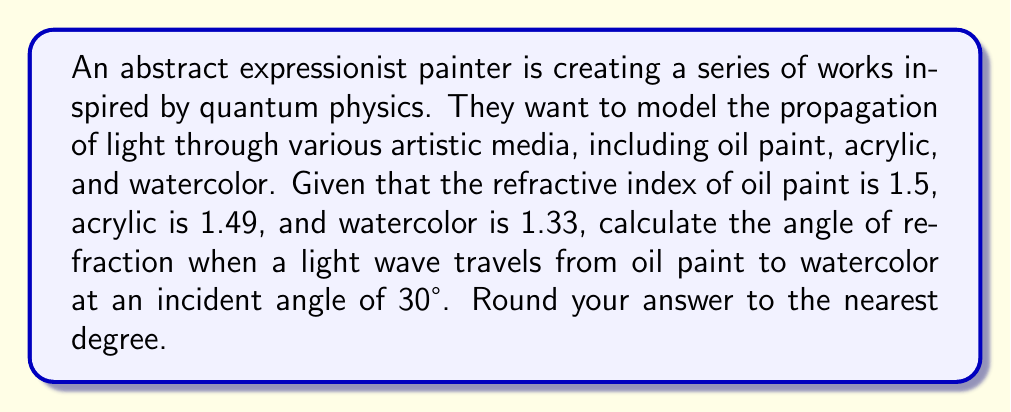Help me with this question. To solve this problem, we'll use Snell's law, which describes the relationship between the angles of incidence and refraction for waves passing through a boundary between two different media:

$$n_1 \sin(\theta_1) = n_2 \sin(\theta_2)$$

Where:
$n_1$ = refractive index of the first medium (oil paint)
$n_2$ = refractive index of the second medium (watercolor)
$\theta_1$ = angle of incidence
$\theta_2$ = angle of refraction (what we're solving for)

Step 1: Identify the known values
$n_1 = 1.5$ (oil paint)
$n_2 = 1.33$ (watercolor)
$\theta_1 = 30°$

Step 2: Rearrange Snell's law to solve for $\theta_2$
$$\theta_2 = \arcsin(\frac{n_1}{n_2} \sin(\theta_1))$$

Step 3: Substitute the known values
$$\theta_2 = \arcsin(\frac{1.5}{1.33} \sin(30°))$$

Step 4: Calculate the result
$$\theta_2 = \arcsin(\frac{1.5}{1.33} \cdot 0.5)$$
$$\theta_2 = \arcsin(0.5639)$$
$$\theta_2 \approx 34.37°$$

Step 5: Round to the nearest degree
$$\theta_2 \approx 34°$$

This result shows that as light moves from oil paint to watercolor, it bends away from the normal, as watercolor has a lower refractive index than oil paint.
Answer: 34° 